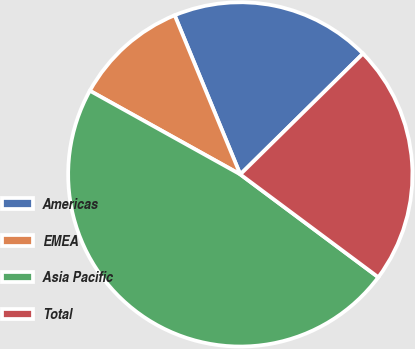<chart> <loc_0><loc_0><loc_500><loc_500><pie_chart><fcel>Americas<fcel>EMEA<fcel>Asia Pacific<fcel>Total<nl><fcel>18.85%<fcel>10.7%<fcel>47.89%<fcel>22.57%<nl></chart> 